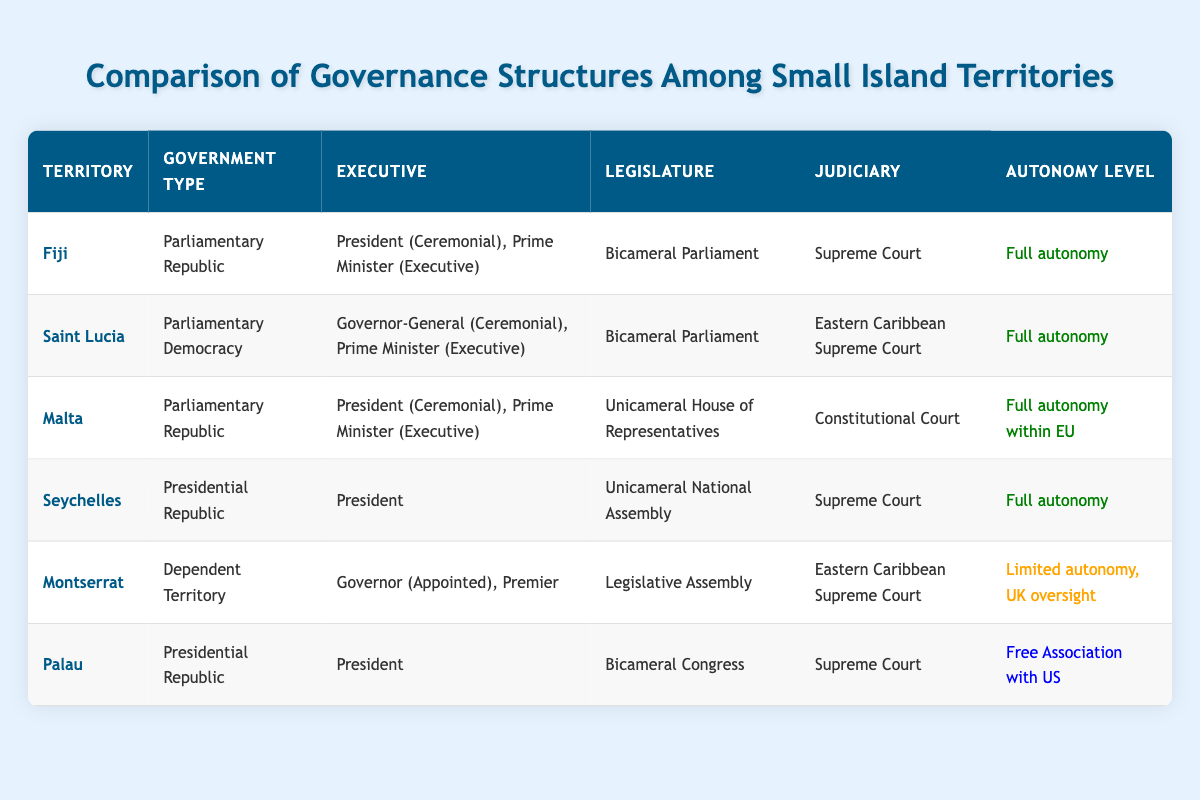What type of government does Fiji have? Fiji is listed under the "government_type" column in the table, where it is identified as a "Parliamentary Republic."
Answer: Parliamentary Republic Which territories have a bicameral legislature? To answer this, I look at the "Legislature" column and see which entries include "Bicameral." Fiji and Saint Lucia both list "Bicameral Parliament," and Palau also has "Bicameral Congress."
Answer: Fiji, Saint Lucia, Palau Is the judiciary in Montserrat the Eastern Caribbean Supreme Court? By checking the "Judiciary" column for Montserrat, it states "Eastern Caribbean Supreme Court," confirming the fact.
Answer: Yes How many territories have full autonomy? I sum the entries in the "Autonomy Level" column that indicate "Full autonomy." Fiji, Saint Lucia, Malta, Seychelles all have this autonomy level, totaling four territories.
Answer: 4 Which territory has the highest level of oversight? I look for "Limited autonomy" in the "Autonomy Level" column. Montserrat is the only territory categorized this way, indicating it has the highest level of oversight.
Answer: Montserrat What is the difference in government type between Seychelles and Palau? I refer to the "government_type" column for both territories. Seychelles is a "Presidential Republic," while Palau is also a "Presidential Republic." Thus, there is no difference in government type between the two.
Answer: No difference Does Saint Lucia have an appointed executive? In the "Executive" column for Saint Lucia, it states "Governor-General (Ceremonial), Prime Minister (Executive)". Since the Governor-General is appointed, the answer is affirmative.
Answer: Yes Which territory has autonomy within the EU? Looking into the "Autonomy Level" column, Malta is stated as having "Full autonomy within EU," making it the only territory with that designation.
Answer: Malta In total, how many different types of judiciaries are mentioned in the table? I examine the "Judiciary" column for distinct entries. The entries listed are "Supreme Court," "Eastern Caribbean Supreme Court," and "Constitutional Court." This gives a total of three unique types of judiciaries.
Answer: 3 